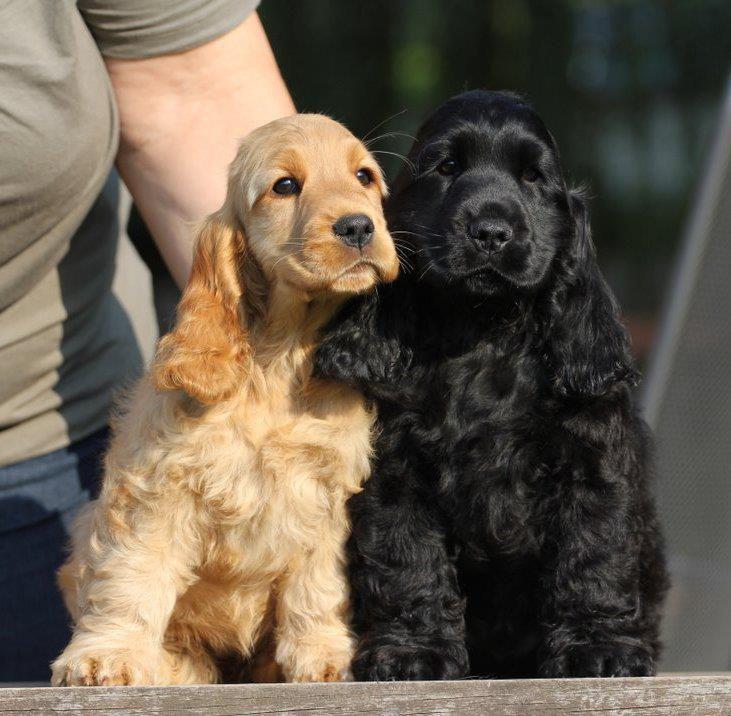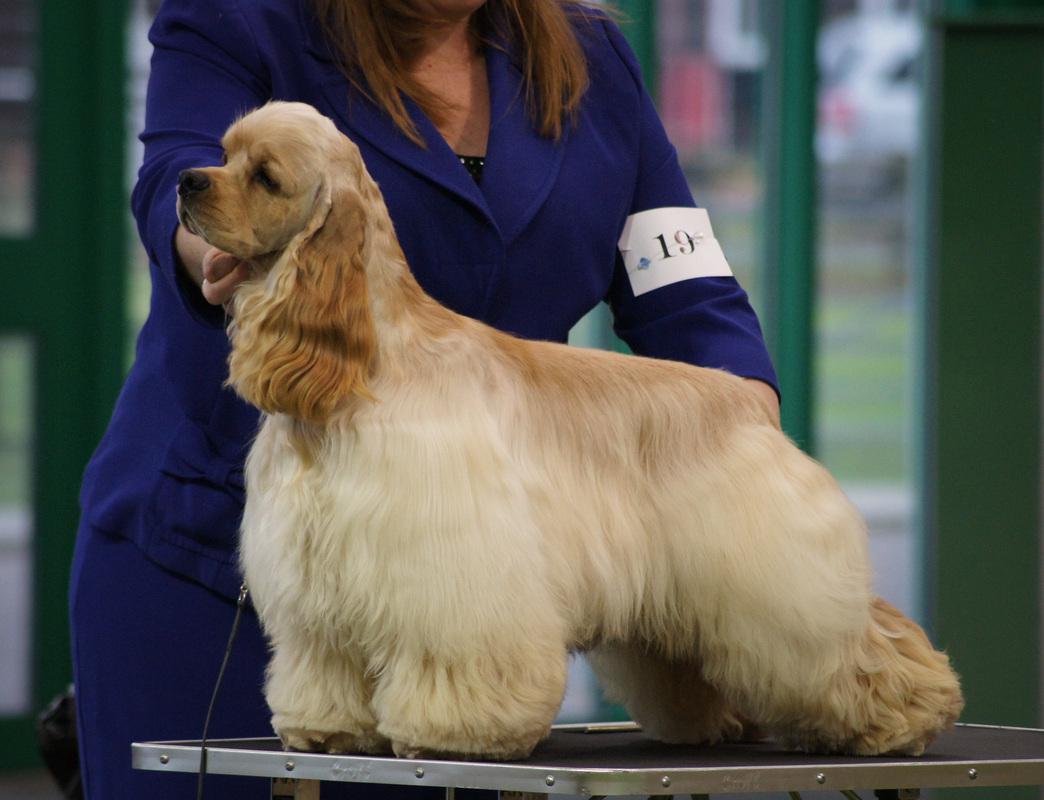The first image is the image on the left, the second image is the image on the right. For the images displayed, is the sentence "Left image shows a person standing behind a left-turned cocker spaniel, holding its chin and tail by a hand." factually correct? Answer yes or no. No. The first image is the image on the left, the second image is the image on the right. Considering the images on both sides, is "There is more than one breed of dog in the image." valid? Answer yes or no. No. 